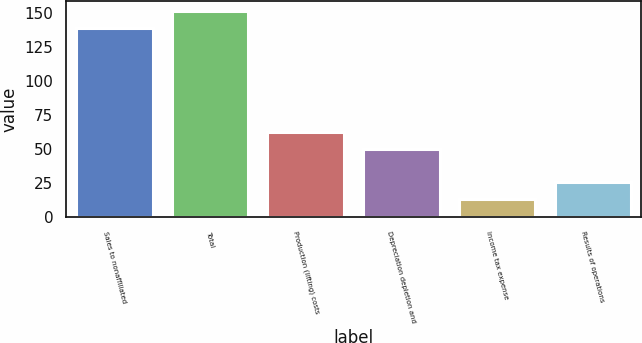<chart> <loc_0><loc_0><loc_500><loc_500><bar_chart><fcel>Sales to nonaffiliated<fcel>Total<fcel>Production (lifting) costs<fcel>Depreciation depletion and<fcel>Income tax expense<fcel>Results of operations<nl><fcel>139<fcel>151.6<fcel>62.6<fcel>50<fcel>13<fcel>25.6<nl></chart> 